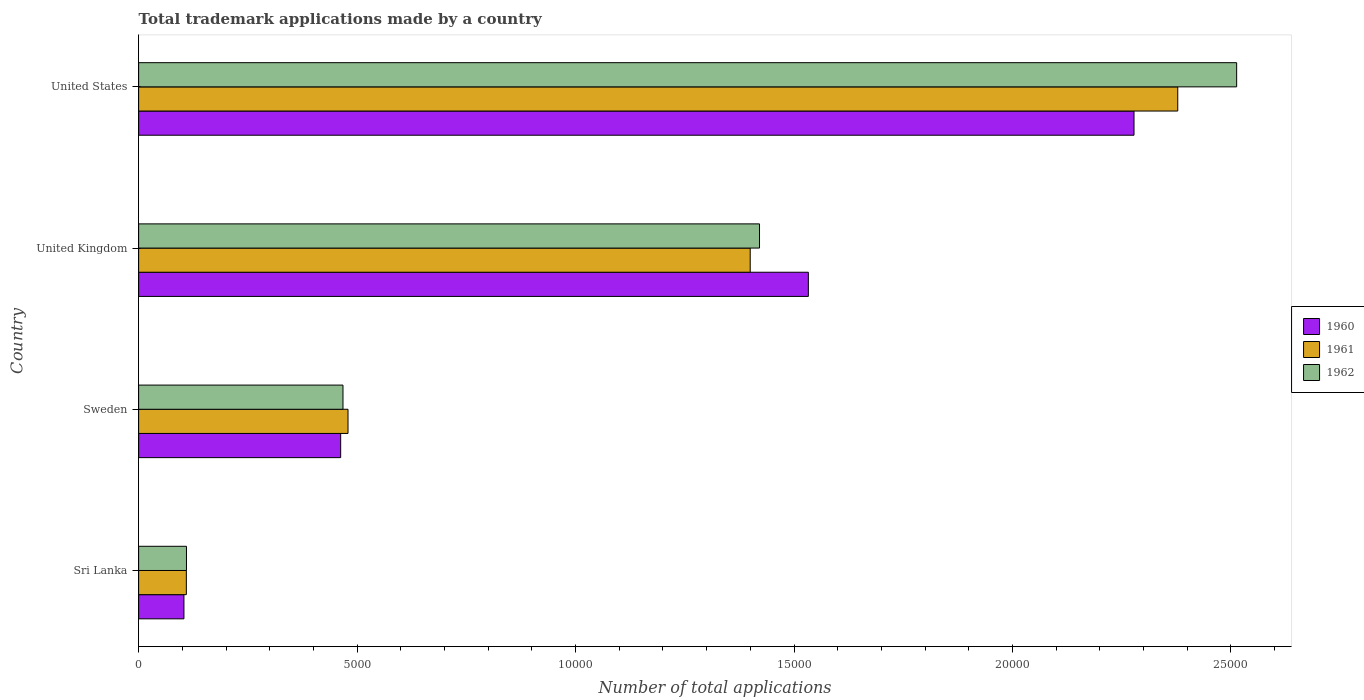How many groups of bars are there?
Your answer should be very brief. 4. Are the number of bars on each tick of the Y-axis equal?
Give a very brief answer. Yes. How many bars are there on the 1st tick from the top?
Ensure brevity in your answer.  3. What is the number of applications made by in 1961 in United States?
Provide a succinct answer. 2.38e+04. Across all countries, what is the maximum number of applications made by in 1962?
Give a very brief answer. 2.51e+04. Across all countries, what is the minimum number of applications made by in 1960?
Your response must be concise. 1037. In which country was the number of applications made by in 1962 maximum?
Keep it short and to the point. United States. In which country was the number of applications made by in 1962 minimum?
Your answer should be compact. Sri Lanka. What is the total number of applications made by in 1960 in the graph?
Offer a very short reply. 4.38e+04. What is the difference between the number of applications made by in 1962 in Sweden and that in United States?
Make the answer very short. -2.05e+04. What is the difference between the number of applications made by in 1961 in Sri Lanka and the number of applications made by in 1962 in United States?
Make the answer very short. -2.40e+04. What is the average number of applications made by in 1960 per country?
Provide a succinct answer. 1.09e+04. What is the difference between the number of applications made by in 1960 and number of applications made by in 1962 in United Kingdom?
Your answer should be very brief. 1118. In how many countries, is the number of applications made by in 1962 greater than 10000 ?
Give a very brief answer. 2. What is the ratio of the number of applications made by in 1960 in Sweden to that in United States?
Your response must be concise. 0.2. Is the number of applications made by in 1962 in Sri Lanka less than that in Sweden?
Your response must be concise. Yes. Is the difference between the number of applications made by in 1960 in Sweden and United Kingdom greater than the difference between the number of applications made by in 1962 in Sweden and United Kingdom?
Your answer should be compact. No. What is the difference between the highest and the second highest number of applications made by in 1961?
Keep it short and to the point. 9785. What is the difference between the highest and the lowest number of applications made by in 1962?
Your answer should be compact. 2.40e+04. What does the 2nd bar from the top in United Kingdom represents?
Offer a very short reply. 1961. What does the 1st bar from the bottom in United Kingdom represents?
Provide a succinct answer. 1960. Is it the case that in every country, the sum of the number of applications made by in 1960 and number of applications made by in 1961 is greater than the number of applications made by in 1962?
Make the answer very short. Yes. How many bars are there?
Provide a short and direct response. 12. Are the values on the major ticks of X-axis written in scientific E-notation?
Your answer should be compact. No. Does the graph contain grids?
Make the answer very short. No. Where does the legend appear in the graph?
Your response must be concise. Center right. How many legend labels are there?
Provide a short and direct response. 3. How are the legend labels stacked?
Keep it short and to the point. Vertical. What is the title of the graph?
Your response must be concise. Total trademark applications made by a country. What is the label or title of the X-axis?
Your response must be concise. Number of total applications. What is the Number of total applications of 1960 in Sri Lanka?
Keep it short and to the point. 1037. What is the Number of total applications of 1961 in Sri Lanka?
Your answer should be very brief. 1092. What is the Number of total applications in 1962 in Sri Lanka?
Make the answer very short. 1095. What is the Number of total applications of 1960 in Sweden?
Give a very brief answer. 4624. What is the Number of total applications in 1961 in Sweden?
Ensure brevity in your answer.  4792. What is the Number of total applications in 1962 in Sweden?
Your response must be concise. 4677. What is the Number of total applications in 1960 in United Kingdom?
Your answer should be compact. 1.53e+04. What is the Number of total applications in 1961 in United Kingdom?
Make the answer very short. 1.40e+04. What is the Number of total applications in 1962 in United Kingdom?
Your answer should be compact. 1.42e+04. What is the Number of total applications in 1960 in United States?
Keep it short and to the point. 2.28e+04. What is the Number of total applications of 1961 in United States?
Give a very brief answer. 2.38e+04. What is the Number of total applications of 1962 in United States?
Give a very brief answer. 2.51e+04. Across all countries, what is the maximum Number of total applications in 1960?
Provide a short and direct response. 2.28e+04. Across all countries, what is the maximum Number of total applications of 1961?
Give a very brief answer. 2.38e+04. Across all countries, what is the maximum Number of total applications in 1962?
Your response must be concise. 2.51e+04. Across all countries, what is the minimum Number of total applications in 1960?
Your answer should be compact. 1037. Across all countries, what is the minimum Number of total applications of 1961?
Your answer should be compact. 1092. Across all countries, what is the minimum Number of total applications of 1962?
Your response must be concise. 1095. What is the total Number of total applications in 1960 in the graph?
Your answer should be compact. 4.38e+04. What is the total Number of total applications of 1961 in the graph?
Offer a very short reply. 4.37e+04. What is the total Number of total applications in 1962 in the graph?
Keep it short and to the point. 4.51e+04. What is the difference between the Number of total applications of 1960 in Sri Lanka and that in Sweden?
Offer a terse response. -3587. What is the difference between the Number of total applications in 1961 in Sri Lanka and that in Sweden?
Offer a terse response. -3700. What is the difference between the Number of total applications in 1962 in Sri Lanka and that in Sweden?
Make the answer very short. -3582. What is the difference between the Number of total applications in 1960 in Sri Lanka and that in United Kingdom?
Keep it short and to the point. -1.43e+04. What is the difference between the Number of total applications in 1961 in Sri Lanka and that in United Kingdom?
Ensure brevity in your answer.  -1.29e+04. What is the difference between the Number of total applications of 1962 in Sri Lanka and that in United Kingdom?
Keep it short and to the point. -1.31e+04. What is the difference between the Number of total applications in 1960 in Sri Lanka and that in United States?
Provide a short and direct response. -2.17e+04. What is the difference between the Number of total applications in 1961 in Sri Lanka and that in United States?
Your answer should be compact. -2.27e+04. What is the difference between the Number of total applications in 1962 in Sri Lanka and that in United States?
Offer a very short reply. -2.40e+04. What is the difference between the Number of total applications of 1960 in Sweden and that in United Kingdom?
Provide a succinct answer. -1.07e+04. What is the difference between the Number of total applications in 1961 in Sweden and that in United Kingdom?
Provide a succinct answer. -9205. What is the difference between the Number of total applications in 1962 in Sweden and that in United Kingdom?
Your answer should be very brief. -9533. What is the difference between the Number of total applications in 1960 in Sweden and that in United States?
Keep it short and to the point. -1.82e+04. What is the difference between the Number of total applications in 1961 in Sweden and that in United States?
Offer a terse response. -1.90e+04. What is the difference between the Number of total applications of 1962 in Sweden and that in United States?
Offer a very short reply. -2.05e+04. What is the difference between the Number of total applications in 1960 in United Kingdom and that in United States?
Your answer should be compact. -7453. What is the difference between the Number of total applications in 1961 in United Kingdom and that in United States?
Offer a very short reply. -9785. What is the difference between the Number of total applications of 1962 in United Kingdom and that in United States?
Give a very brief answer. -1.09e+04. What is the difference between the Number of total applications of 1960 in Sri Lanka and the Number of total applications of 1961 in Sweden?
Provide a short and direct response. -3755. What is the difference between the Number of total applications of 1960 in Sri Lanka and the Number of total applications of 1962 in Sweden?
Make the answer very short. -3640. What is the difference between the Number of total applications in 1961 in Sri Lanka and the Number of total applications in 1962 in Sweden?
Your answer should be compact. -3585. What is the difference between the Number of total applications of 1960 in Sri Lanka and the Number of total applications of 1961 in United Kingdom?
Ensure brevity in your answer.  -1.30e+04. What is the difference between the Number of total applications in 1960 in Sri Lanka and the Number of total applications in 1962 in United Kingdom?
Keep it short and to the point. -1.32e+04. What is the difference between the Number of total applications in 1961 in Sri Lanka and the Number of total applications in 1962 in United Kingdom?
Your answer should be very brief. -1.31e+04. What is the difference between the Number of total applications of 1960 in Sri Lanka and the Number of total applications of 1961 in United States?
Keep it short and to the point. -2.27e+04. What is the difference between the Number of total applications in 1960 in Sri Lanka and the Number of total applications in 1962 in United States?
Your answer should be very brief. -2.41e+04. What is the difference between the Number of total applications in 1961 in Sri Lanka and the Number of total applications in 1962 in United States?
Make the answer very short. -2.40e+04. What is the difference between the Number of total applications of 1960 in Sweden and the Number of total applications of 1961 in United Kingdom?
Your answer should be very brief. -9373. What is the difference between the Number of total applications in 1960 in Sweden and the Number of total applications in 1962 in United Kingdom?
Provide a short and direct response. -9586. What is the difference between the Number of total applications in 1961 in Sweden and the Number of total applications in 1962 in United Kingdom?
Your response must be concise. -9418. What is the difference between the Number of total applications in 1960 in Sweden and the Number of total applications in 1961 in United States?
Your answer should be very brief. -1.92e+04. What is the difference between the Number of total applications in 1960 in Sweden and the Number of total applications in 1962 in United States?
Provide a succinct answer. -2.05e+04. What is the difference between the Number of total applications in 1961 in Sweden and the Number of total applications in 1962 in United States?
Offer a terse response. -2.03e+04. What is the difference between the Number of total applications in 1960 in United Kingdom and the Number of total applications in 1961 in United States?
Keep it short and to the point. -8454. What is the difference between the Number of total applications in 1960 in United Kingdom and the Number of total applications in 1962 in United States?
Ensure brevity in your answer.  -9802. What is the difference between the Number of total applications in 1961 in United Kingdom and the Number of total applications in 1962 in United States?
Ensure brevity in your answer.  -1.11e+04. What is the average Number of total applications of 1960 per country?
Provide a short and direct response. 1.09e+04. What is the average Number of total applications of 1961 per country?
Your answer should be compact. 1.09e+04. What is the average Number of total applications of 1962 per country?
Offer a terse response. 1.13e+04. What is the difference between the Number of total applications in 1960 and Number of total applications in 1961 in Sri Lanka?
Your answer should be very brief. -55. What is the difference between the Number of total applications in 1960 and Number of total applications in 1962 in Sri Lanka?
Keep it short and to the point. -58. What is the difference between the Number of total applications in 1960 and Number of total applications in 1961 in Sweden?
Give a very brief answer. -168. What is the difference between the Number of total applications in 1960 and Number of total applications in 1962 in Sweden?
Offer a very short reply. -53. What is the difference between the Number of total applications in 1961 and Number of total applications in 1962 in Sweden?
Offer a very short reply. 115. What is the difference between the Number of total applications of 1960 and Number of total applications of 1961 in United Kingdom?
Provide a succinct answer. 1331. What is the difference between the Number of total applications of 1960 and Number of total applications of 1962 in United Kingdom?
Offer a terse response. 1118. What is the difference between the Number of total applications in 1961 and Number of total applications in 1962 in United Kingdom?
Your answer should be very brief. -213. What is the difference between the Number of total applications of 1960 and Number of total applications of 1961 in United States?
Provide a short and direct response. -1001. What is the difference between the Number of total applications in 1960 and Number of total applications in 1962 in United States?
Offer a terse response. -2349. What is the difference between the Number of total applications of 1961 and Number of total applications of 1962 in United States?
Your answer should be compact. -1348. What is the ratio of the Number of total applications of 1960 in Sri Lanka to that in Sweden?
Offer a terse response. 0.22. What is the ratio of the Number of total applications of 1961 in Sri Lanka to that in Sweden?
Provide a succinct answer. 0.23. What is the ratio of the Number of total applications in 1962 in Sri Lanka to that in Sweden?
Give a very brief answer. 0.23. What is the ratio of the Number of total applications in 1960 in Sri Lanka to that in United Kingdom?
Give a very brief answer. 0.07. What is the ratio of the Number of total applications in 1961 in Sri Lanka to that in United Kingdom?
Give a very brief answer. 0.08. What is the ratio of the Number of total applications of 1962 in Sri Lanka to that in United Kingdom?
Offer a terse response. 0.08. What is the ratio of the Number of total applications in 1960 in Sri Lanka to that in United States?
Your response must be concise. 0.05. What is the ratio of the Number of total applications of 1961 in Sri Lanka to that in United States?
Keep it short and to the point. 0.05. What is the ratio of the Number of total applications of 1962 in Sri Lanka to that in United States?
Ensure brevity in your answer.  0.04. What is the ratio of the Number of total applications in 1960 in Sweden to that in United Kingdom?
Your answer should be compact. 0.3. What is the ratio of the Number of total applications in 1961 in Sweden to that in United Kingdom?
Provide a short and direct response. 0.34. What is the ratio of the Number of total applications in 1962 in Sweden to that in United Kingdom?
Ensure brevity in your answer.  0.33. What is the ratio of the Number of total applications in 1960 in Sweden to that in United States?
Provide a succinct answer. 0.2. What is the ratio of the Number of total applications of 1961 in Sweden to that in United States?
Your answer should be compact. 0.2. What is the ratio of the Number of total applications of 1962 in Sweden to that in United States?
Provide a succinct answer. 0.19. What is the ratio of the Number of total applications of 1960 in United Kingdom to that in United States?
Ensure brevity in your answer.  0.67. What is the ratio of the Number of total applications of 1961 in United Kingdom to that in United States?
Keep it short and to the point. 0.59. What is the ratio of the Number of total applications in 1962 in United Kingdom to that in United States?
Ensure brevity in your answer.  0.57. What is the difference between the highest and the second highest Number of total applications in 1960?
Provide a short and direct response. 7453. What is the difference between the highest and the second highest Number of total applications in 1961?
Your answer should be compact. 9785. What is the difference between the highest and the second highest Number of total applications of 1962?
Provide a succinct answer. 1.09e+04. What is the difference between the highest and the lowest Number of total applications in 1960?
Provide a short and direct response. 2.17e+04. What is the difference between the highest and the lowest Number of total applications of 1961?
Your answer should be compact. 2.27e+04. What is the difference between the highest and the lowest Number of total applications in 1962?
Ensure brevity in your answer.  2.40e+04. 